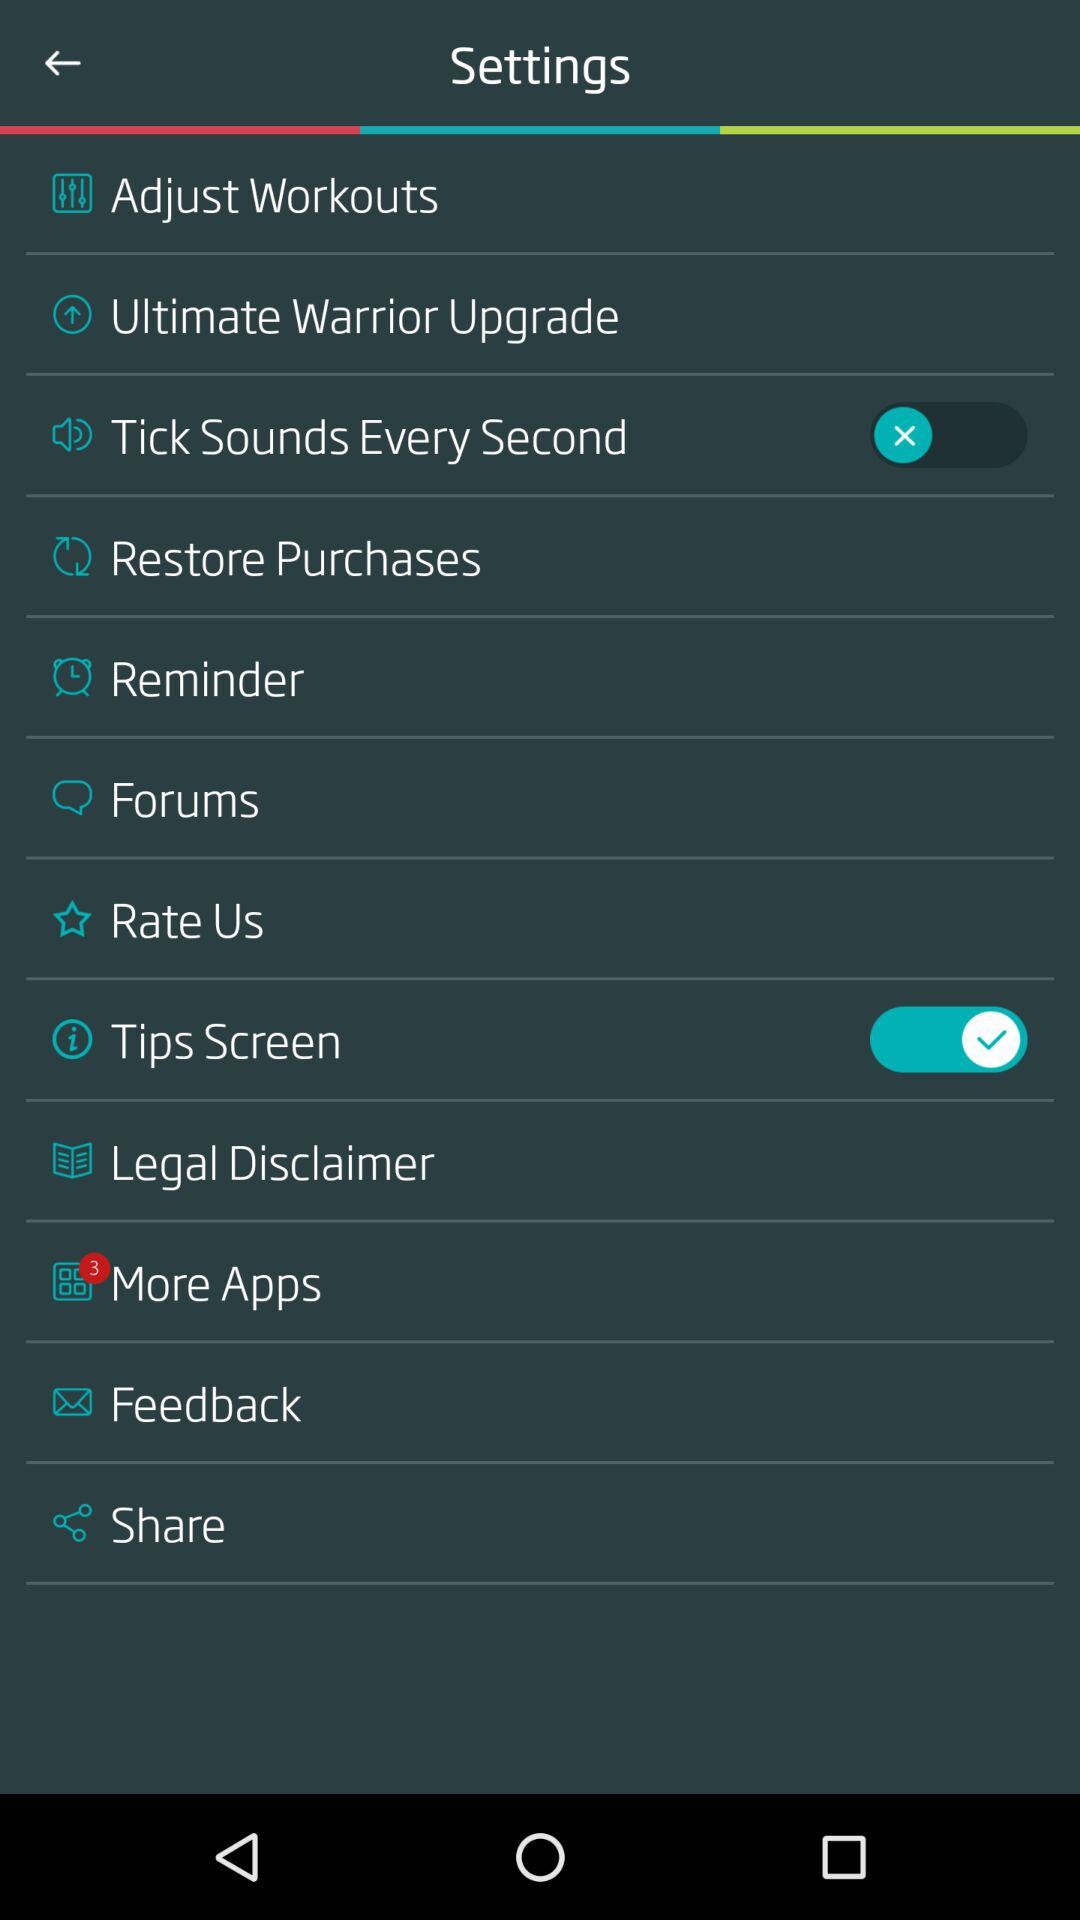What is the status of "Tips Screen"? The status is "on". 